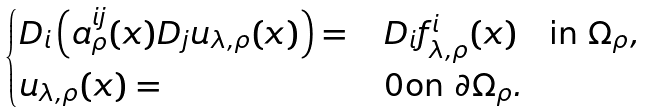Convert formula to latex. <formula><loc_0><loc_0><loc_500><loc_500>\begin{cases} D _ { i } \left ( a _ { \rho } ^ { i j } ( x ) D _ { j } u _ { \lambda , \rho } ( x ) \right ) = & \, D _ { i } f _ { \lambda , \rho } ^ { i } ( x ) \quad \text {in} \ \Omega _ { \rho } , \ \, \\ u _ { \lambda , \rho } ( x ) = & \, 0 \text {on} \ \partial \Omega _ { \rho } . \end{cases}</formula> 